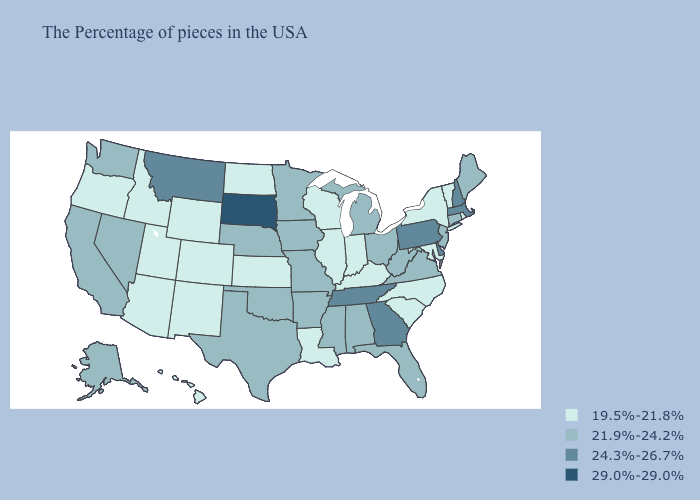Name the states that have a value in the range 19.5%-21.8%?
Be succinct. Rhode Island, Vermont, New York, Maryland, North Carolina, South Carolina, Kentucky, Indiana, Wisconsin, Illinois, Louisiana, Kansas, North Dakota, Wyoming, Colorado, New Mexico, Utah, Arizona, Idaho, Oregon, Hawaii. Does Maine have a lower value than Oklahoma?
Quick response, please. No. Among the states that border Minnesota , does North Dakota have the highest value?
Keep it brief. No. How many symbols are there in the legend?
Short answer required. 4. Is the legend a continuous bar?
Quick response, please. No. What is the value of Massachusetts?
Keep it brief. 24.3%-26.7%. What is the lowest value in the West?
Answer briefly. 19.5%-21.8%. Does Colorado have the same value as North Dakota?
Be succinct. Yes. Name the states that have a value in the range 24.3%-26.7%?
Quick response, please. Massachusetts, New Hampshire, Delaware, Pennsylvania, Georgia, Tennessee, Montana. Which states have the lowest value in the USA?
Quick response, please. Rhode Island, Vermont, New York, Maryland, North Carolina, South Carolina, Kentucky, Indiana, Wisconsin, Illinois, Louisiana, Kansas, North Dakota, Wyoming, Colorado, New Mexico, Utah, Arizona, Idaho, Oregon, Hawaii. Name the states that have a value in the range 29.0%-29.0%?
Answer briefly. South Dakota. What is the lowest value in states that border Nevada?
Answer briefly. 19.5%-21.8%. Which states have the lowest value in the South?
Give a very brief answer. Maryland, North Carolina, South Carolina, Kentucky, Louisiana. Name the states that have a value in the range 24.3%-26.7%?
Quick response, please. Massachusetts, New Hampshire, Delaware, Pennsylvania, Georgia, Tennessee, Montana. Does the map have missing data?
Concise answer only. No. 